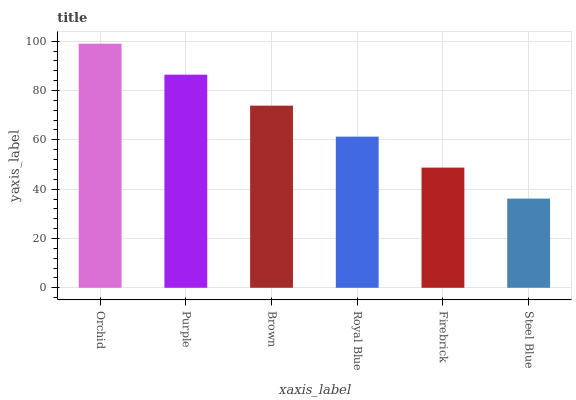Is Steel Blue the minimum?
Answer yes or no. Yes. Is Orchid the maximum?
Answer yes or no. Yes. Is Purple the minimum?
Answer yes or no. No. Is Purple the maximum?
Answer yes or no. No. Is Orchid greater than Purple?
Answer yes or no. Yes. Is Purple less than Orchid?
Answer yes or no. Yes. Is Purple greater than Orchid?
Answer yes or no. No. Is Orchid less than Purple?
Answer yes or no. No. Is Brown the high median?
Answer yes or no. Yes. Is Royal Blue the low median?
Answer yes or no. Yes. Is Firebrick the high median?
Answer yes or no. No. Is Firebrick the low median?
Answer yes or no. No. 